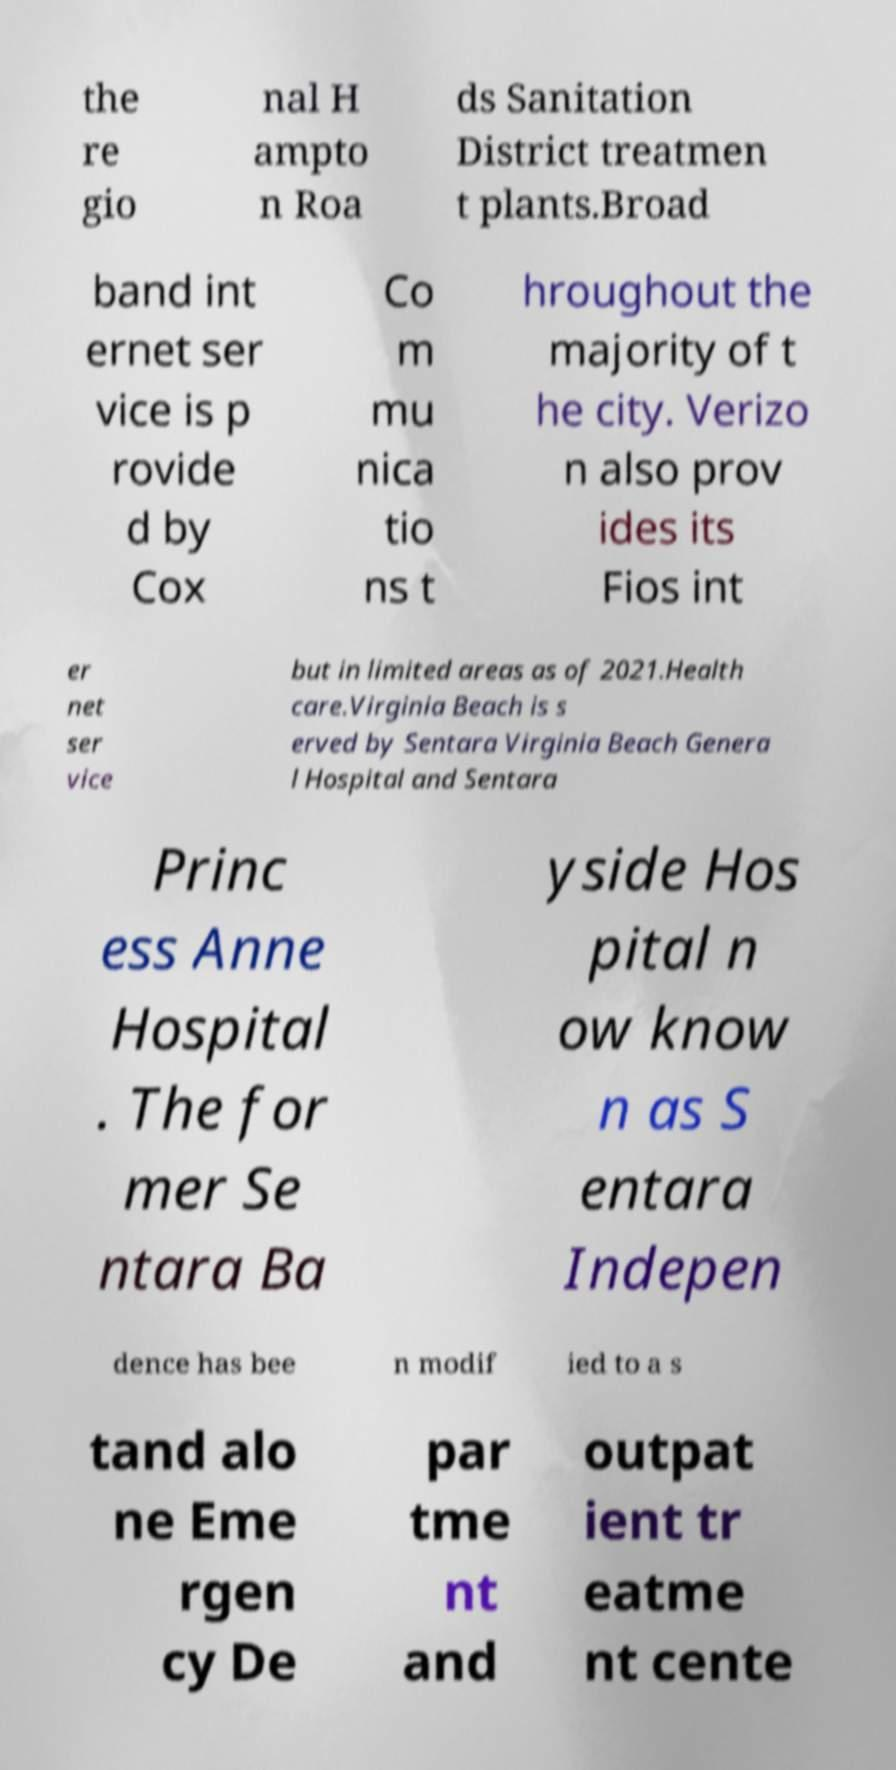There's text embedded in this image that I need extracted. Can you transcribe it verbatim? the re gio nal H ampto n Roa ds Sanitation District treatmen t plants.Broad band int ernet ser vice is p rovide d by Cox Co m mu nica tio ns t hroughout the majority of t he city. Verizo n also prov ides its Fios int er net ser vice but in limited areas as of 2021.Health care.Virginia Beach is s erved by Sentara Virginia Beach Genera l Hospital and Sentara Princ ess Anne Hospital . The for mer Se ntara Ba yside Hos pital n ow know n as S entara Indepen dence has bee n modif ied to a s tand alo ne Eme rgen cy De par tme nt and outpat ient tr eatme nt cente 